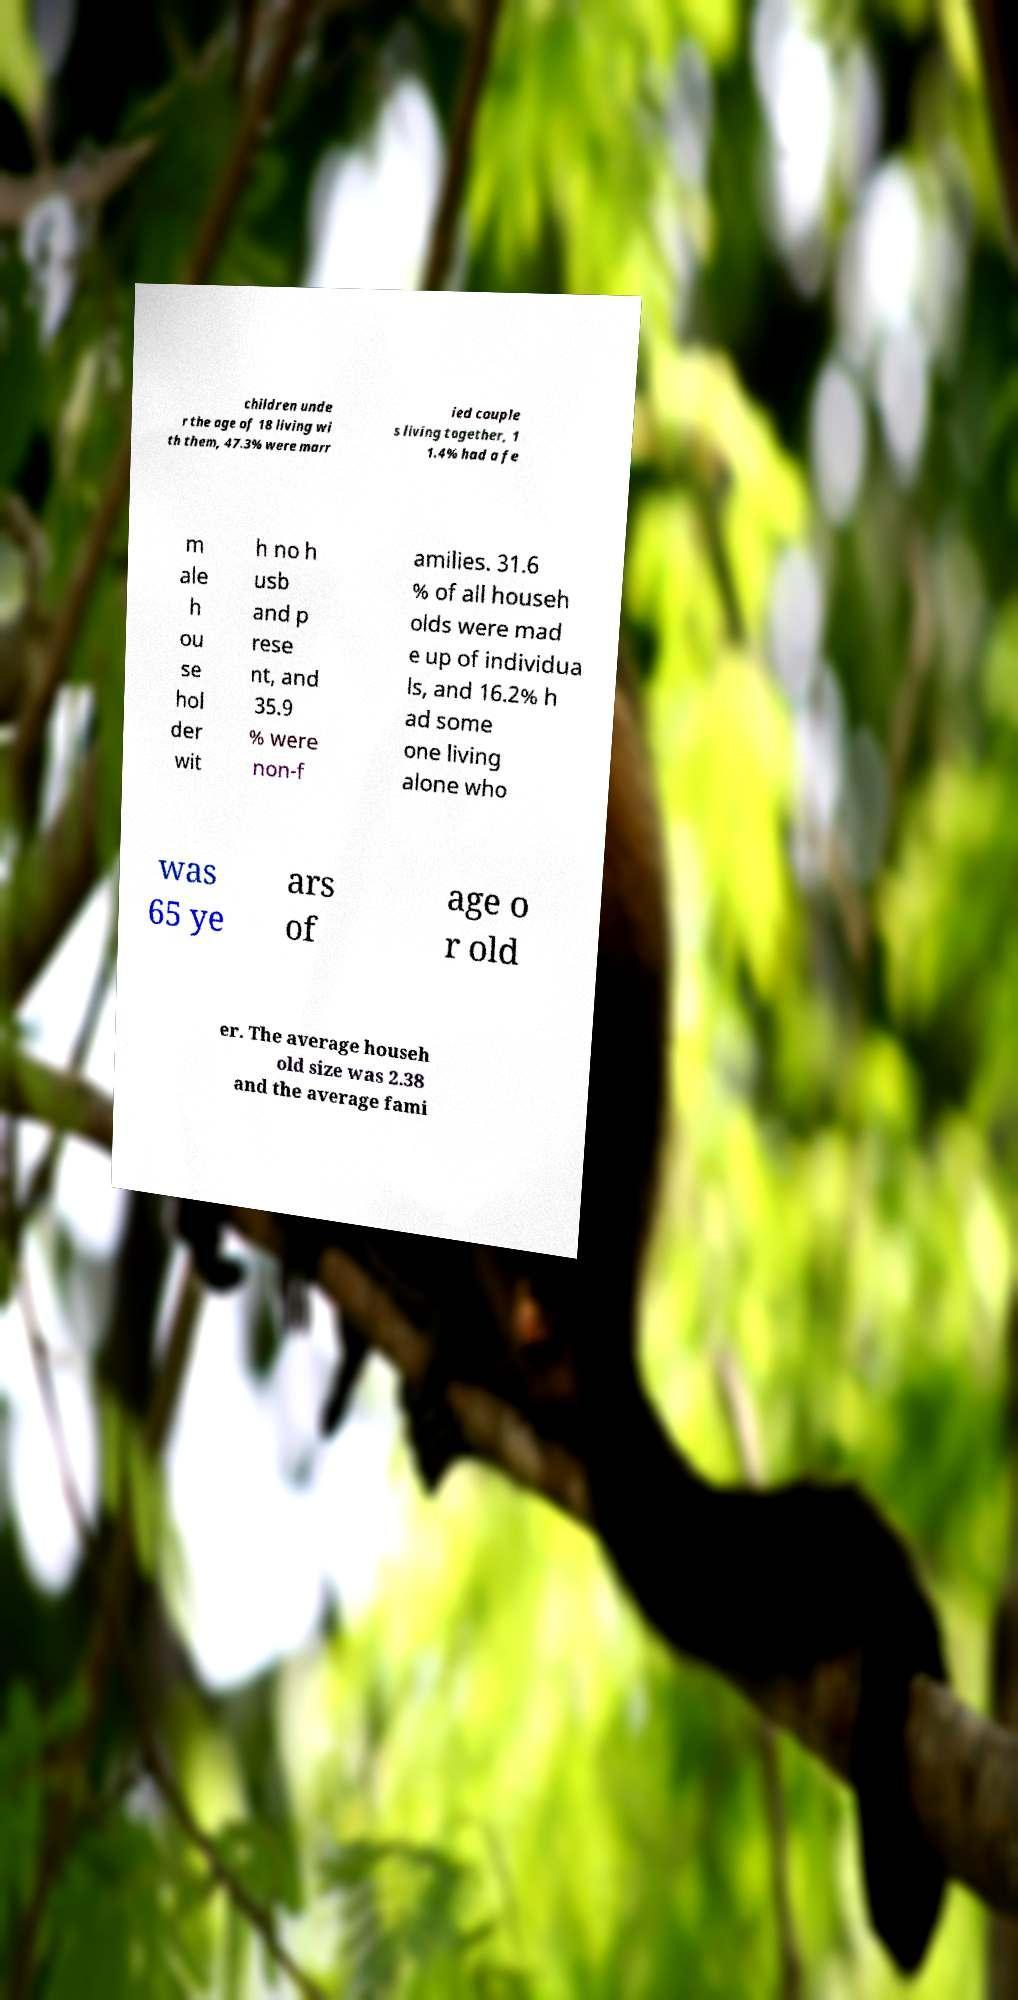Could you extract and type out the text from this image? children unde r the age of 18 living wi th them, 47.3% were marr ied couple s living together, 1 1.4% had a fe m ale h ou se hol der wit h no h usb and p rese nt, and 35.9 % were non-f amilies. 31.6 % of all househ olds were mad e up of individua ls, and 16.2% h ad some one living alone who was 65 ye ars of age o r old er. The average househ old size was 2.38 and the average fami 